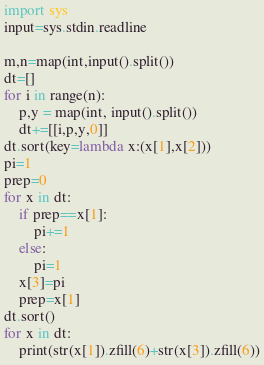Convert code to text. <code><loc_0><loc_0><loc_500><loc_500><_Python_>import sys
input=sys.stdin.readline

m,n=map(int,input().split())
dt=[]
for i in range(n):
    p,y = map(int, input().split())
    dt+=[[i,p,y,0]]
dt.sort(key=lambda x:(x[1],x[2]))
pi=1
prep=0
for x in dt:
    if prep==x[1]:
        pi+=1
    else:
        pi=1
    x[3]=pi
    prep=x[1]
dt.sort()
for x in dt:
    print(str(x[1]).zfill(6)+str(x[3]).zfill(6))</code> 